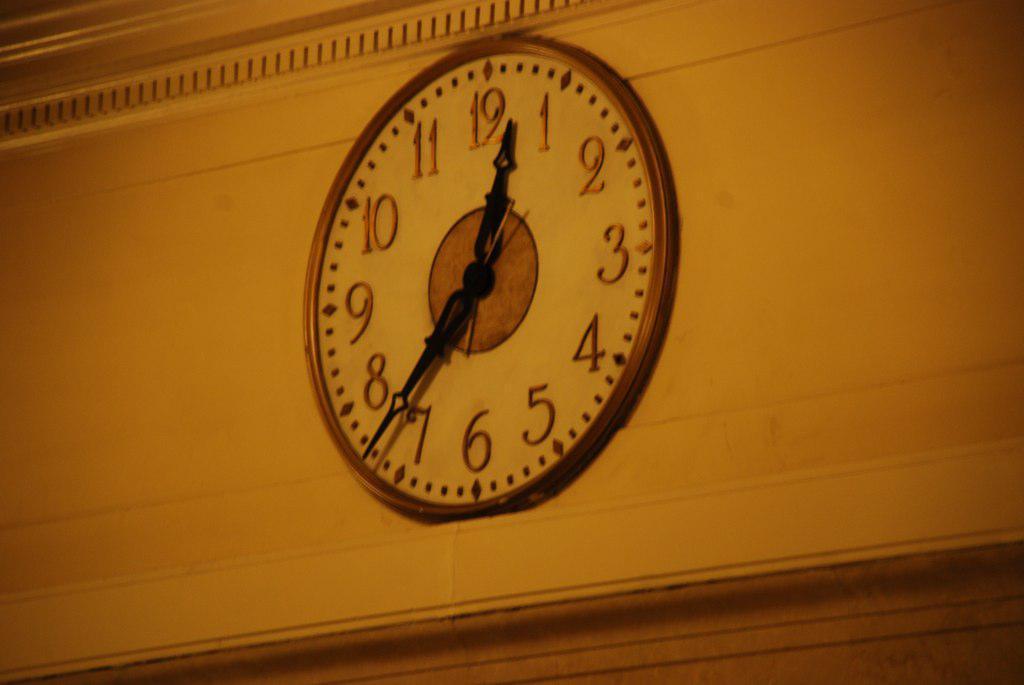How would you summarize this image in a sentence or two? In this image we can see a clock on the wall. There is a wall in the image. 